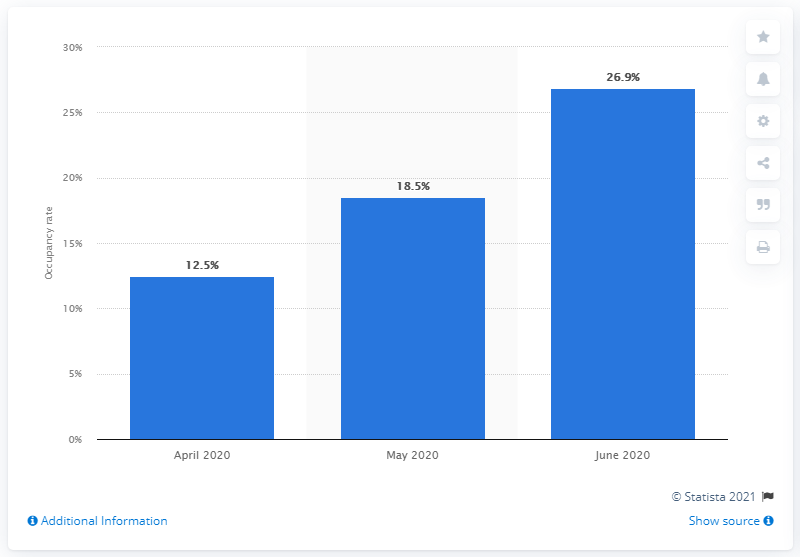Give some essential details in this illustration. In June 2020, the occupancy rate of London hotels was 26.9%. 